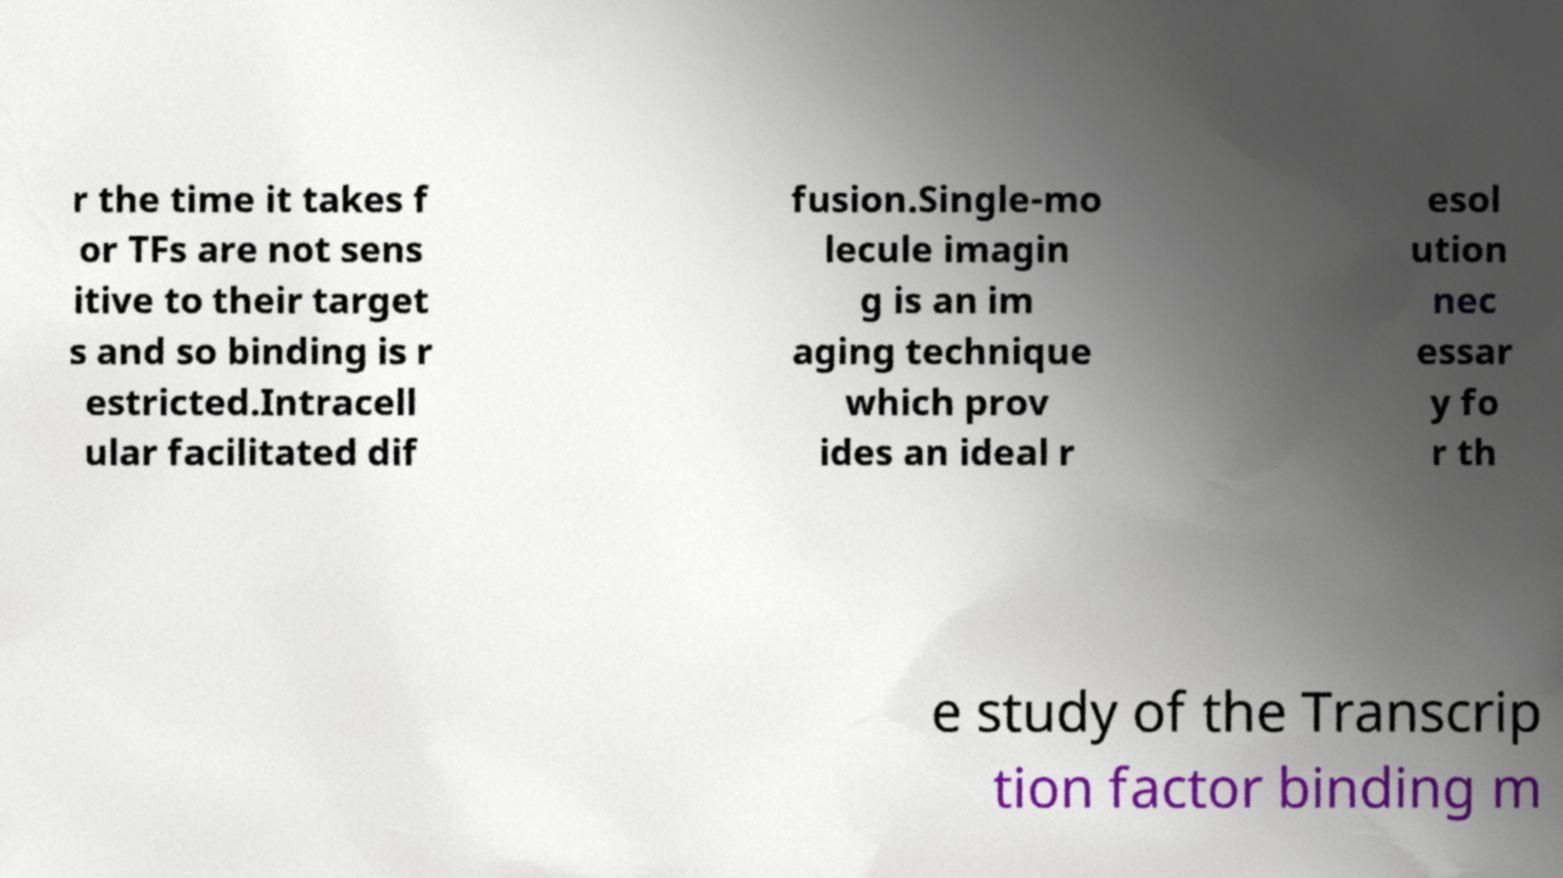I need the written content from this picture converted into text. Can you do that? r the time it takes f or TFs are not sens itive to their target s and so binding is r estricted.Intracell ular facilitated dif fusion.Single-mo lecule imagin g is an im aging technique which prov ides an ideal r esol ution nec essar y fo r th e study of the Transcrip tion factor binding m 